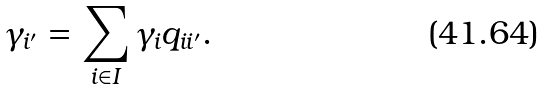<formula> <loc_0><loc_0><loc_500><loc_500>\gamma _ { i ^ { \prime } } = \sum _ { i \in I } \gamma _ { i } q _ { i i ^ { \prime } } .</formula> 